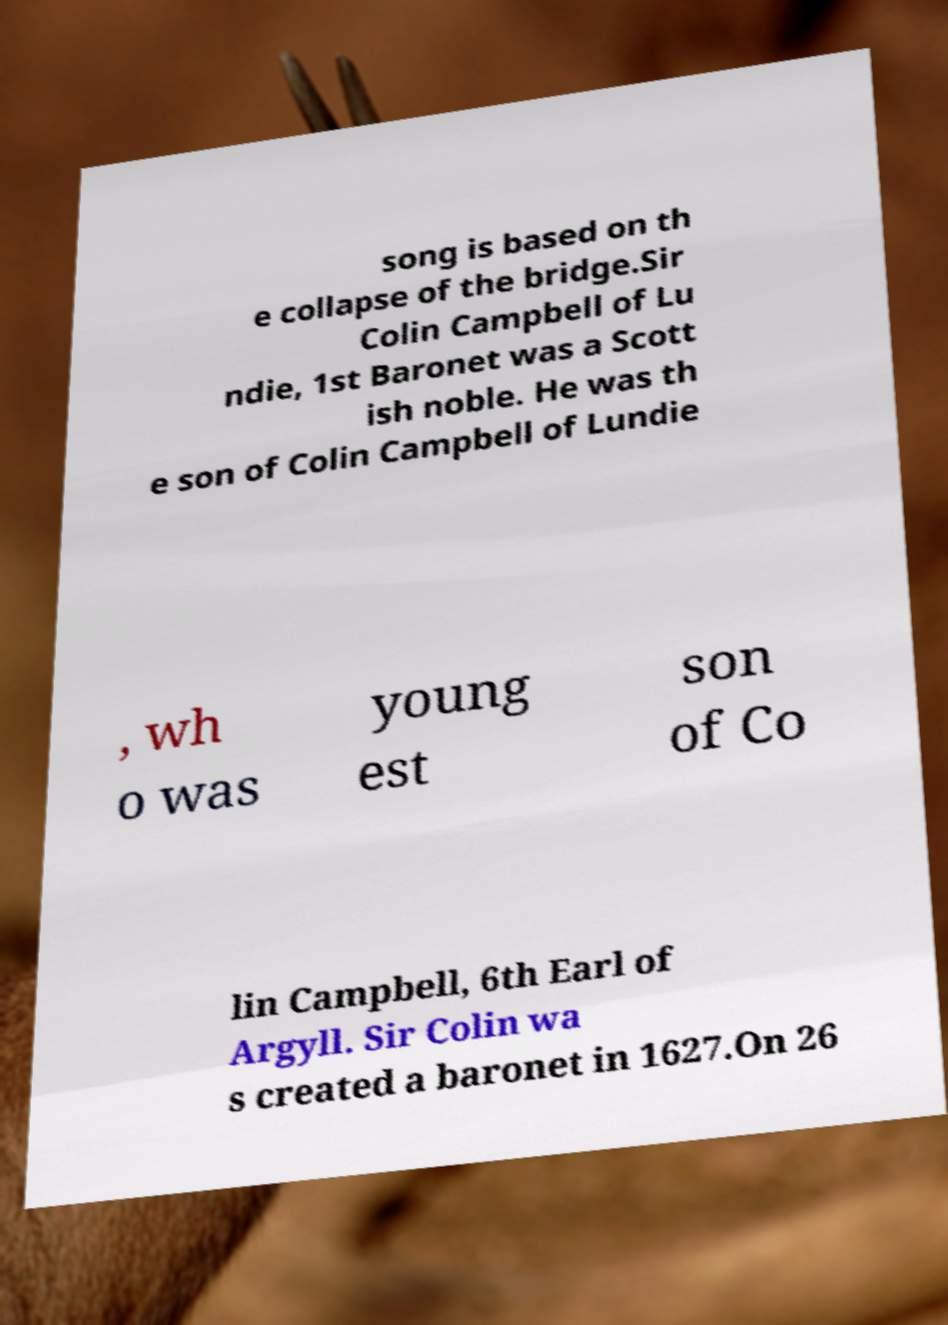Could you assist in decoding the text presented in this image and type it out clearly? song is based on th e collapse of the bridge.Sir Colin Campbell of Lu ndie, 1st Baronet was a Scott ish noble. He was th e son of Colin Campbell of Lundie , wh o was young est son of Co lin Campbell, 6th Earl of Argyll. Sir Colin wa s created a baronet in 1627.On 26 